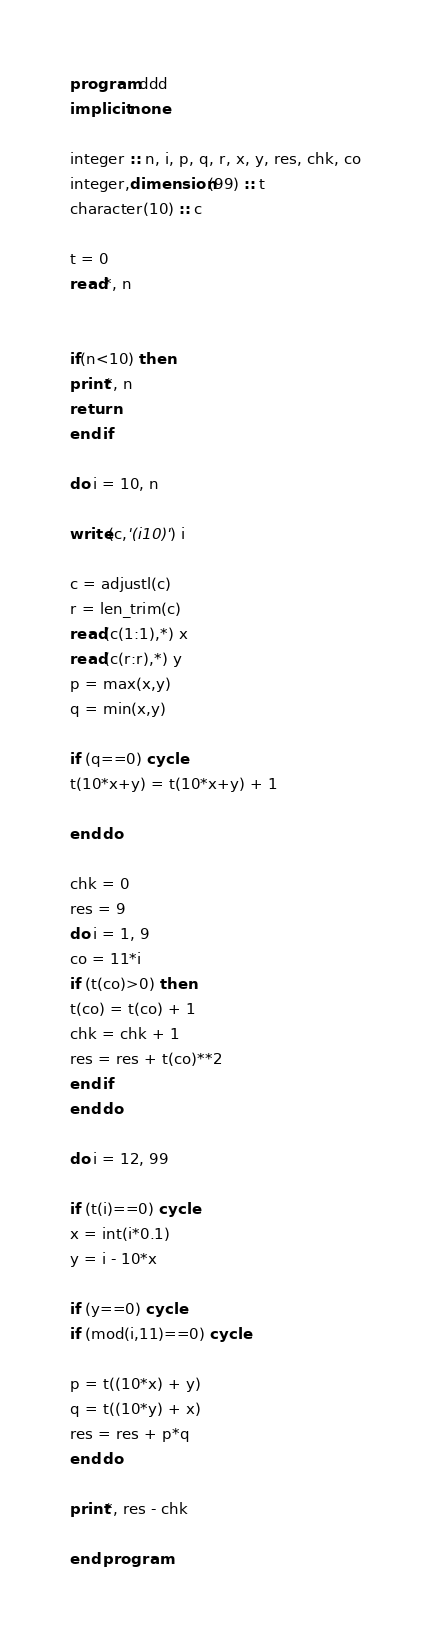<code> <loc_0><loc_0><loc_500><loc_500><_FORTRAN_>program ddd
implicit none

integer :: n, i, p, q, r, x, y, res, chk, co
integer,dimension(99) :: t
character(10) :: c

t = 0
read*, n


if(n<10) then
print*, n
return
end if

do i = 10, n

write(c,'(i10)') i

c = adjustl(c)
r = len_trim(c)
read(c(1:1),*) x
read(c(r:r),*) y
p = max(x,y)
q = min(x,y)

if (q==0) cycle
t(10*x+y) = t(10*x+y) + 1

end do

chk = 0
res = 9
do i = 1, 9
co = 11*i
if (t(co)>0) then
t(co) = t(co) + 1
chk = chk + 1
res = res + t(co)**2
end if
end do

do i = 12, 99

if (t(i)==0) cycle
x = int(i*0.1)
y = i - 10*x

if (y==0) cycle
if (mod(i,11)==0) cycle

p = t((10*x) + y)
q = t((10*y) + x)
res = res + p*q
end do

print*, res - chk

end program</code> 